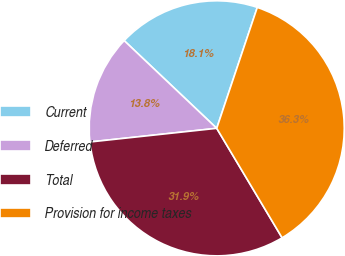<chart> <loc_0><loc_0><loc_500><loc_500><pie_chart><fcel>Current<fcel>Deferred<fcel>Total<fcel>Provision for income taxes<nl><fcel>18.08%<fcel>13.78%<fcel>31.86%<fcel>36.28%<nl></chart> 